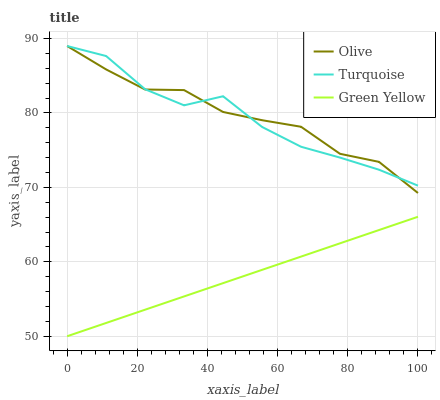Does Turquoise have the minimum area under the curve?
Answer yes or no. No. Does Turquoise have the maximum area under the curve?
Answer yes or no. No. Is Turquoise the smoothest?
Answer yes or no. No. Is Green Yellow the roughest?
Answer yes or no. No. Does Turquoise have the lowest value?
Answer yes or no. No. Does Green Yellow have the highest value?
Answer yes or no. No. Is Green Yellow less than Turquoise?
Answer yes or no. Yes. Is Olive greater than Green Yellow?
Answer yes or no. Yes. Does Green Yellow intersect Turquoise?
Answer yes or no. No. 